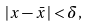<formula> <loc_0><loc_0><loc_500><loc_500>| x - \bar { x } | < \delta ,</formula> 